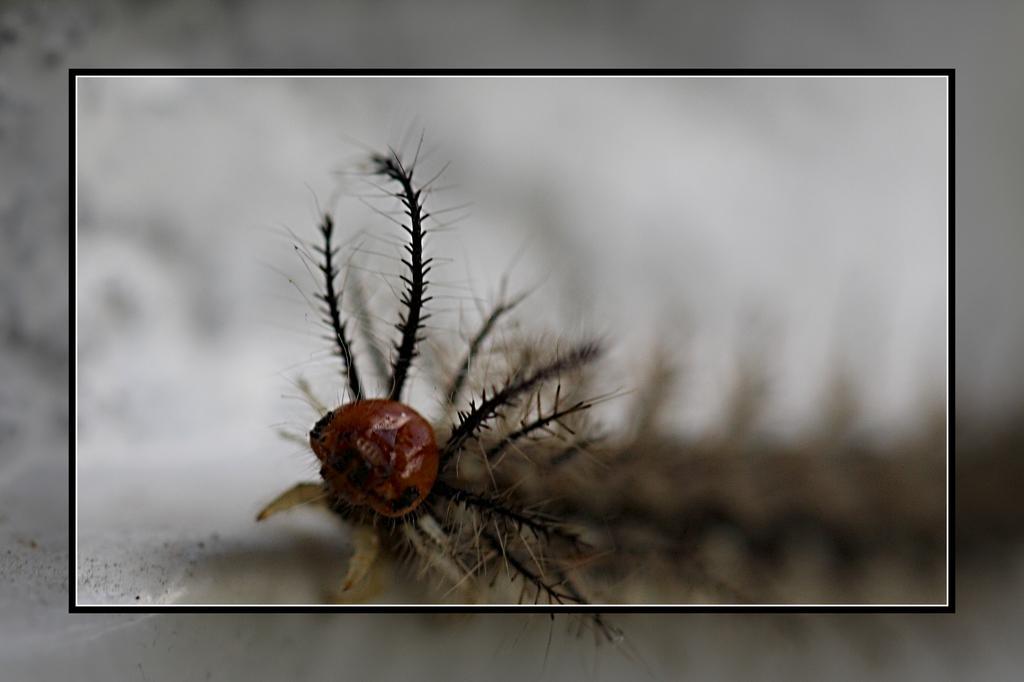In one or two sentences, can you explain what this image depicts? In this picture there is an insect. The background is blurred. The picture has a frame. 